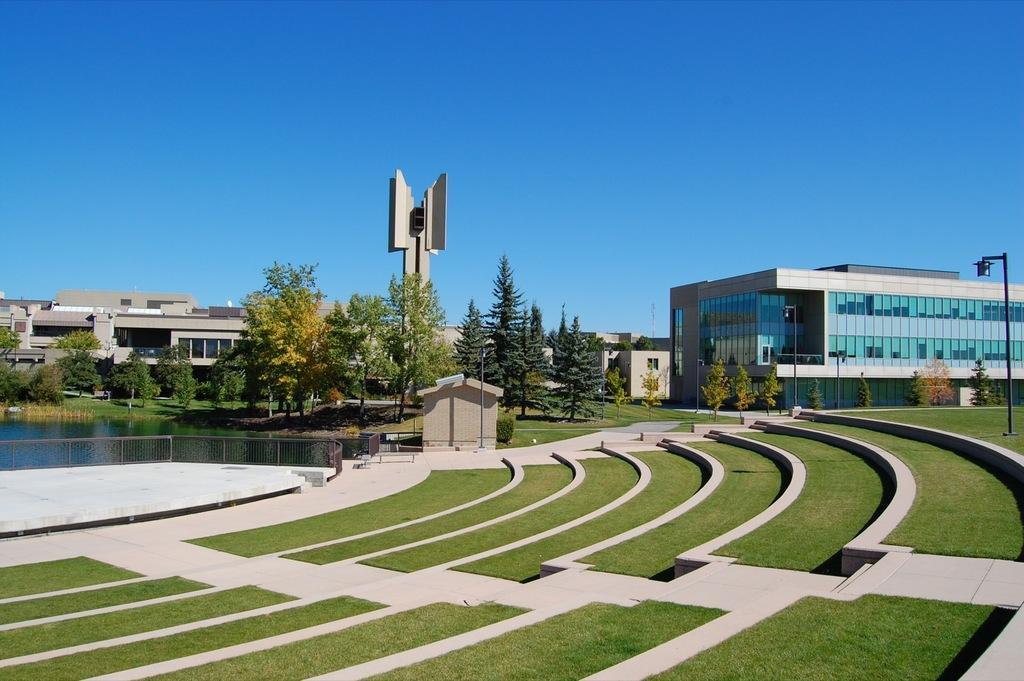Can you describe this image briefly? In this Image I can see the ground. To the left there is a railing and the water. To the right I can see the light pole. In the back there are trees, buildings and the blue sky. 